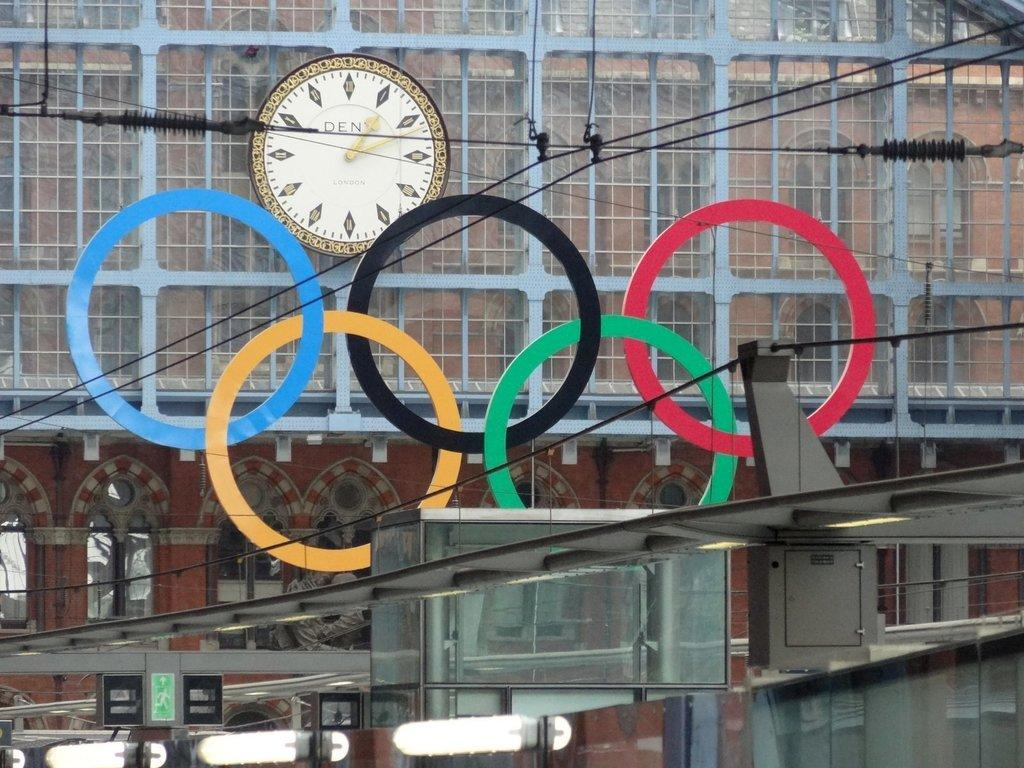<image>
Describe the image concisely. The Olympic rings are displayed utside in front of a large clock that shows the time to be 1:11. 